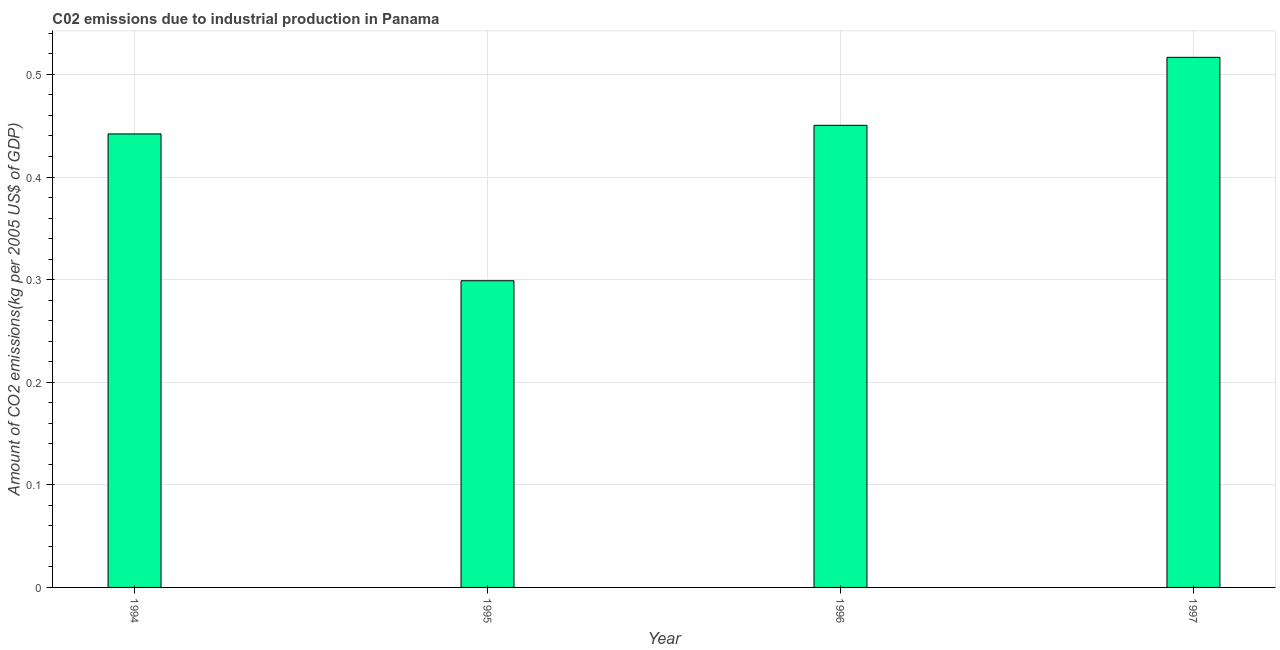Does the graph contain grids?
Make the answer very short. Yes. What is the title of the graph?
Your answer should be compact. C02 emissions due to industrial production in Panama. What is the label or title of the X-axis?
Your answer should be compact. Year. What is the label or title of the Y-axis?
Your answer should be compact. Amount of CO2 emissions(kg per 2005 US$ of GDP). What is the amount of co2 emissions in 1996?
Ensure brevity in your answer.  0.45. Across all years, what is the maximum amount of co2 emissions?
Your response must be concise. 0.52. Across all years, what is the minimum amount of co2 emissions?
Give a very brief answer. 0.3. In which year was the amount of co2 emissions maximum?
Make the answer very short. 1997. What is the sum of the amount of co2 emissions?
Ensure brevity in your answer.  1.71. What is the difference between the amount of co2 emissions in 1995 and 1996?
Ensure brevity in your answer.  -0.15. What is the average amount of co2 emissions per year?
Offer a terse response. 0.43. What is the median amount of co2 emissions?
Keep it short and to the point. 0.45. In how many years, is the amount of co2 emissions greater than 0.36 kg per 2005 US$ of GDP?
Give a very brief answer. 3. Do a majority of the years between 1997 and 1996 (inclusive) have amount of co2 emissions greater than 0.08 kg per 2005 US$ of GDP?
Offer a terse response. No. What is the ratio of the amount of co2 emissions in 1994 to that in 1997?
Your response must be concise. 0.86. Is the difference between the amount of co2 emissions in 1995 and 1996 greater than the difference between any two years?
Provide a succinct answer. No. What is the difference between the highest and the second highest amount of co2 emissions?
Provide a succinct answer. 0.07. Is the sum of the amount of co2 emissions in 1994 and 1997 greater than the maximum amount of co2 emissions across all years?
Provide a short and direct response. Yes. What is the difference between the highest and the lowest amount of co2 emissions?
Provide a succinct answer. 0.22. Are all the bars in the graph horizontal?
Provide a short and direct response. No. How many years are there in the graph?
Your answer should be very brief. 4. What is the Amount of CO2 emissions(kg per 2005 US$ of GDP) of 1994?
Your answer should be compact. 0.44. What is the Amount of CO2 emissions(kg per 2005 US$ of GDP) of 1995?
Keep it short and to the point. 0.3. What is the Amount of CO2 emissions(kg per 2005 US$ of GDP) in 1996?
Your answer should be very brief. 0.45. What is the Amount of CO2 emissions(kg per 2005 US$ of GDP) of 1997?
Provide a short and direct response. 0.52. What is the difference between the Amount of CO2 emissions(kg per 2005 US$ of GDP) in 1994 and 1995?
Keep it short and to the point. 0.14. What is the difference between the Amount of CO2 emissions(kg per 2005 US$ of GDP) in 1994 and 1996?
Offer a terse response. -0.01. What is the difference between the Amount of CO2 emissions(kg per 2005 US$ of GDP) in 1994 and 1997?
Your response must be concise. -0.07. What is the difference between the Amount of CO2 emissions(kg per 2005 US$ of GDP) in 1995 and 1996?
Your answer should be compact. -0.15. What is the difference between the Amount of CO2 emissions(kg per 2005 US$ of GDP) in 1995 and 1997?
Give a very brief answer. -0.22. What is the difference between the Amount of CO2 emissions(kg per 2005 US$ of GDP) in 1996 and 1997?
Your answer should be compact. -0.07. What is the ratio of the Amount of CO2 emissions(kg per 2005 US$ of GDP) in 1994 to that in 1995?
Offer a terse response. 1.48. What is the ratio of the Amount of CO2 emissions(kg per 2005 US$ of GDP) in 1994 to that in 1996?
Give a very brief answer. 0.98. What is the ratio of the Amount of CO2 emissions(kg per 2005 US$ of GDP) in 1994 to that in 1997?
Give a very brief answer. 0.86. What is the ratio of the Amount of CO2 emissions(kg per 2005 US$ of GDP) in 1995 to that in 1996?
Offer a terse response. 0.66. What is the ratio of the Amount of CO2 emissions(kg per 2005 US$ of GDP) in 1995 to that in 1997?
Provide a succinct answer. 0.58. What is the ratio of the Amount of CO2 emissions(kg per 2005 US$ of GDP) in 1996 to that in 1997?
Ensure brevity in your answer.  0.87. 